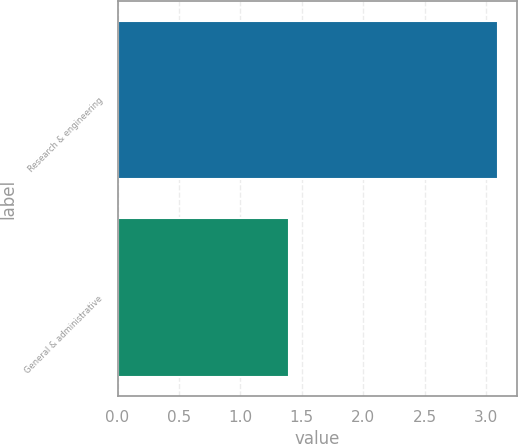Convert chart. <chart><loc_0><loc_0><loc_500><loc_500><bar_chart><fcel>Research & engineering<fcel>General & administrative<nl><fcel>3.1<fcel>1.4<nl></chart> 